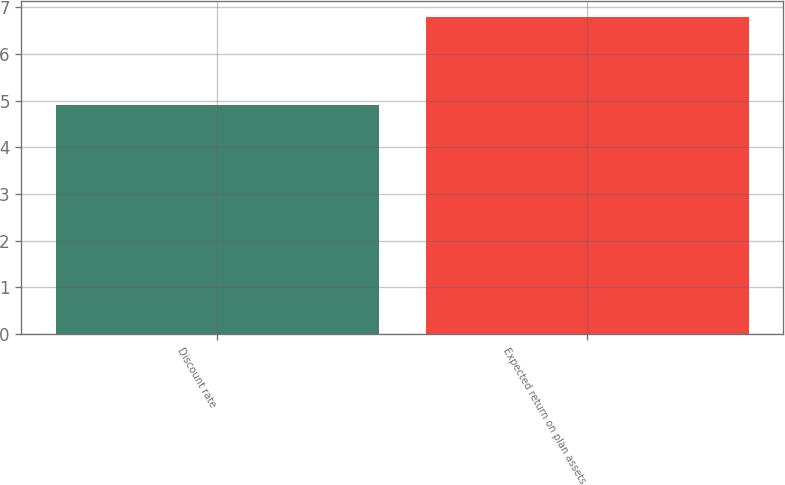<chart> <loc_0><loc_0><loc_500><loc_500><bar_chart><fcel>Discount rate<fcel>Expected return on plan assets<nl><fcel>4.9<fcel>6.8<nl></chart> 